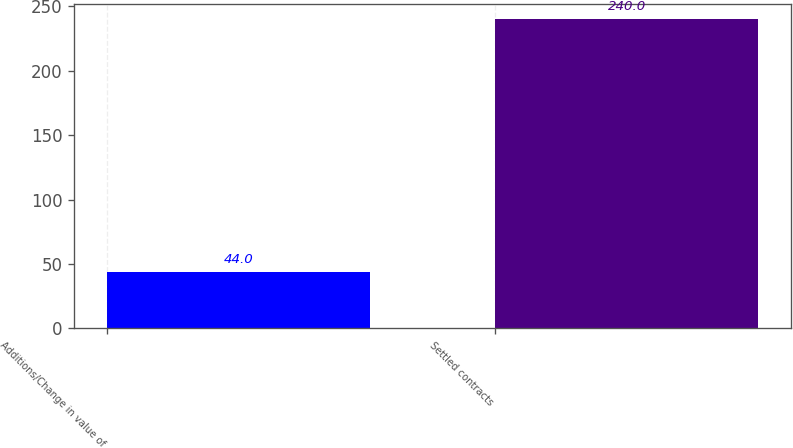Convert chart to OTSL. <chart><loc_0><loc_0><loc_500><loc_500><bar_chart><fcel>Additions/Change in value of<fcel>Settled contracts<nl><fcel>44<fcel>240<nl></chart> 